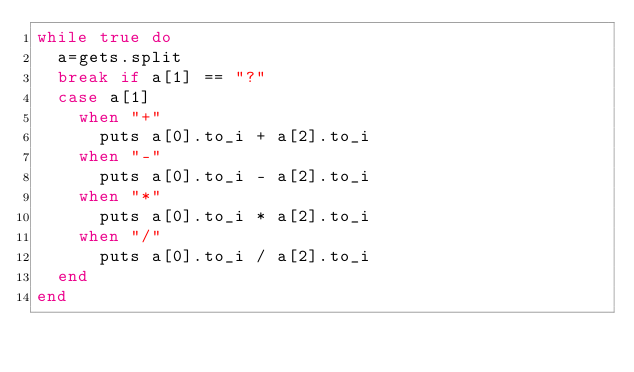Convert code to text. <code><loc_0><loc_0><loc_500><loc_500><_Ruby_>while true do
  a=gets.split
  break if a[1] == "?"
  case a[1]
    when "+"
      puts a[0].to_i + a[2].to_i
    when "-"
      puts a[0].to_i - a[2].to_i
    when "*"
      puts a[0].to_i * a[2].to_i
    when "/"
      puts a[0].to_i / a[2].to_i
  end
end</code> 